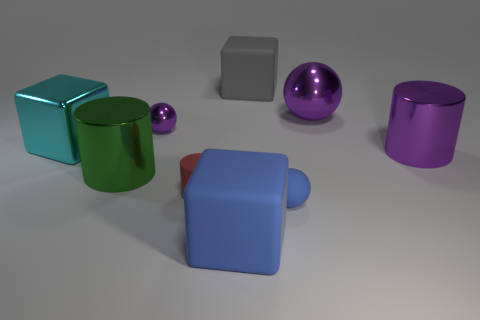Add 1 green objects. How many objects exist? 10 Subtract all cylinders. How many objects are left? 6 Subtract all big purple metal cylinders. Subtract all tiny spheres. How many objects are left? 6 Add 5 large metal cubes. How many large metal cubes are left? 6 Add 1 big blocks. How many big blocks exist? 4 Subtract 0 brown balls. How many objects are left? 9 